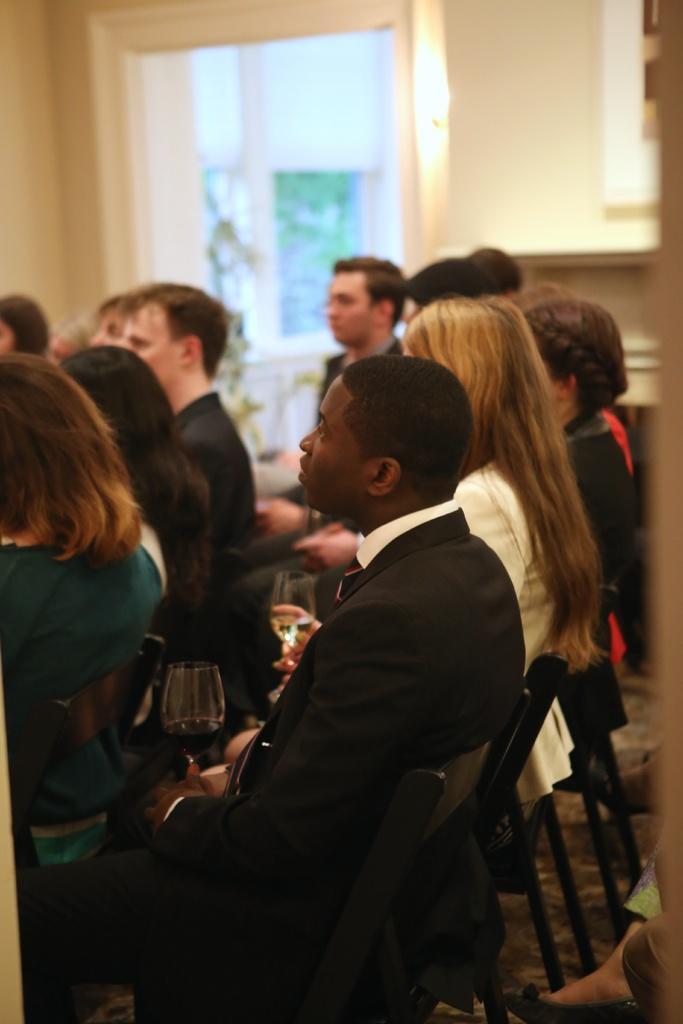How would you summarize this image in a sentence or two? In the image we can see there are many people wearing clothes, they are sitting on the chair, this is a wine glass, window and a floor. 